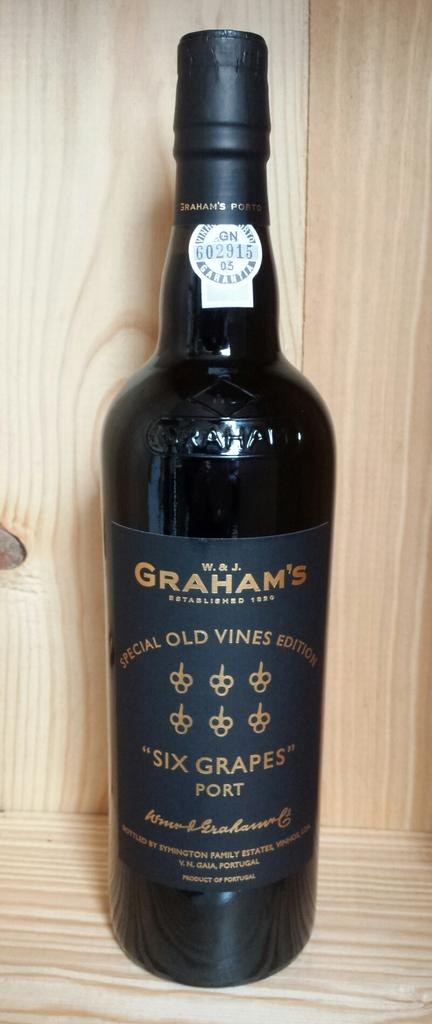<image>
Share a concise interpretation of the image provided. A bottle is labeled as a special old vines edition. 